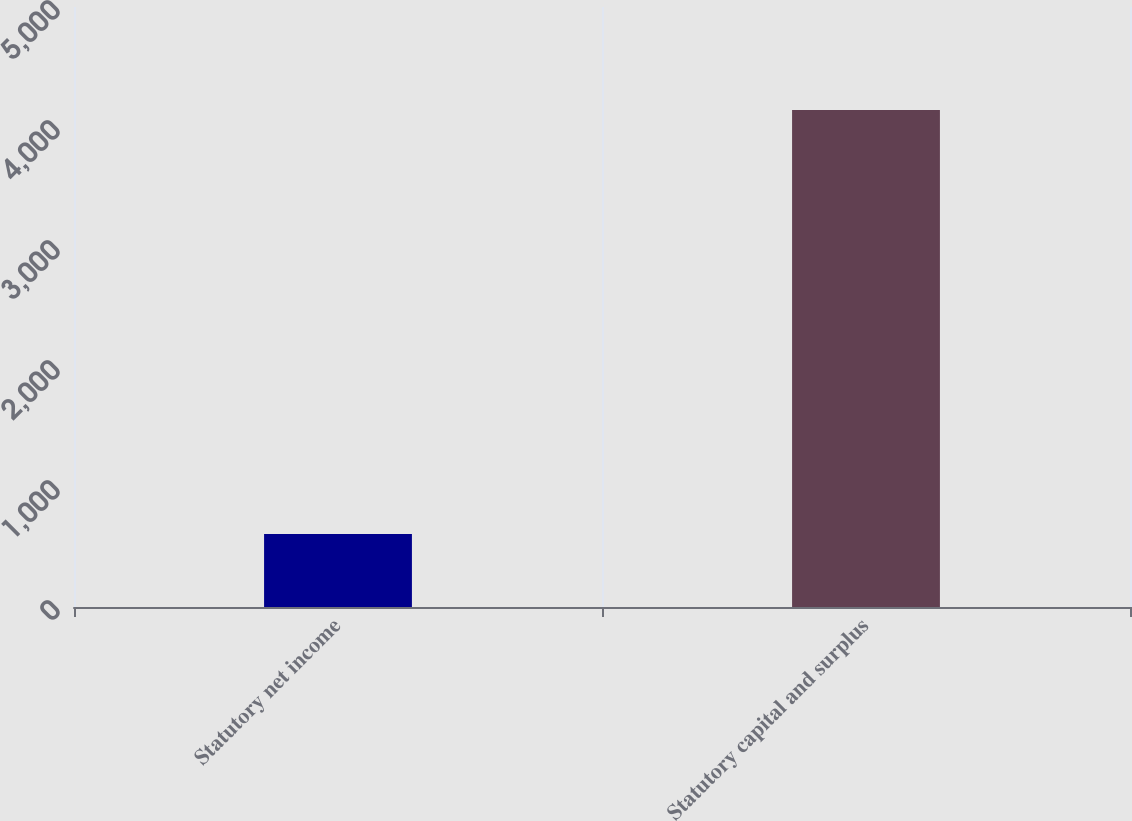Convert chart. <chart><loc_0><loc_0><loc_500><loc_500><bar_chart><fcel>Statutory net income<fcel>Statutory capital and surplus<nl><fcel>607.9<fcel>4142.2<nl></chart> 